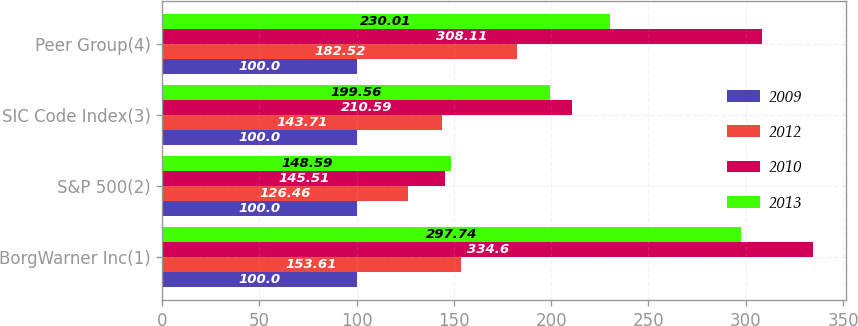Convert chart to OTSL. <chart><loc_0><loc_0><loc_500><loc_500><stacked_bar_chart><ecel><fcel>BorgWarner Inc(1)<fcel>S&P 500(2)<fcel>SIC Code Index(3)<fcel>Peer Group(4)<nl><fcel>2009<fcel>100<fcel>100<fcel>100<fcel>100<nl><fcel>2012<fcel>153.61<fcel>126.46<fcel>143.71<fcel>182.52<nl><fcel>2010<fcel>334.6<fcel>145.51<fcel>210.59<fcel>308.11<nl><fcel>2013<fcel>297.74<fcel>148.59<fcel>199.56<fcel>230.01<nl></chart> 